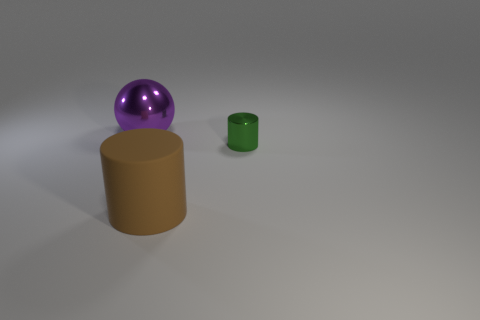Subtract all green cylinders. How many cylinders are left? 1 Add 3 green metallic cylinders. How many objects exist? 6 Subtract all spheres. How many objects are left? 2 Add 2 metallic blocks. How many metallic blocks exist? 2 Subtract 0 cyan cylinders. How many objects are left? 3 Subtract all purple rubber cubes. Subtract all cylinders. How many objects are left? 1 Add 3 small objects. How many small objects are left? 4 